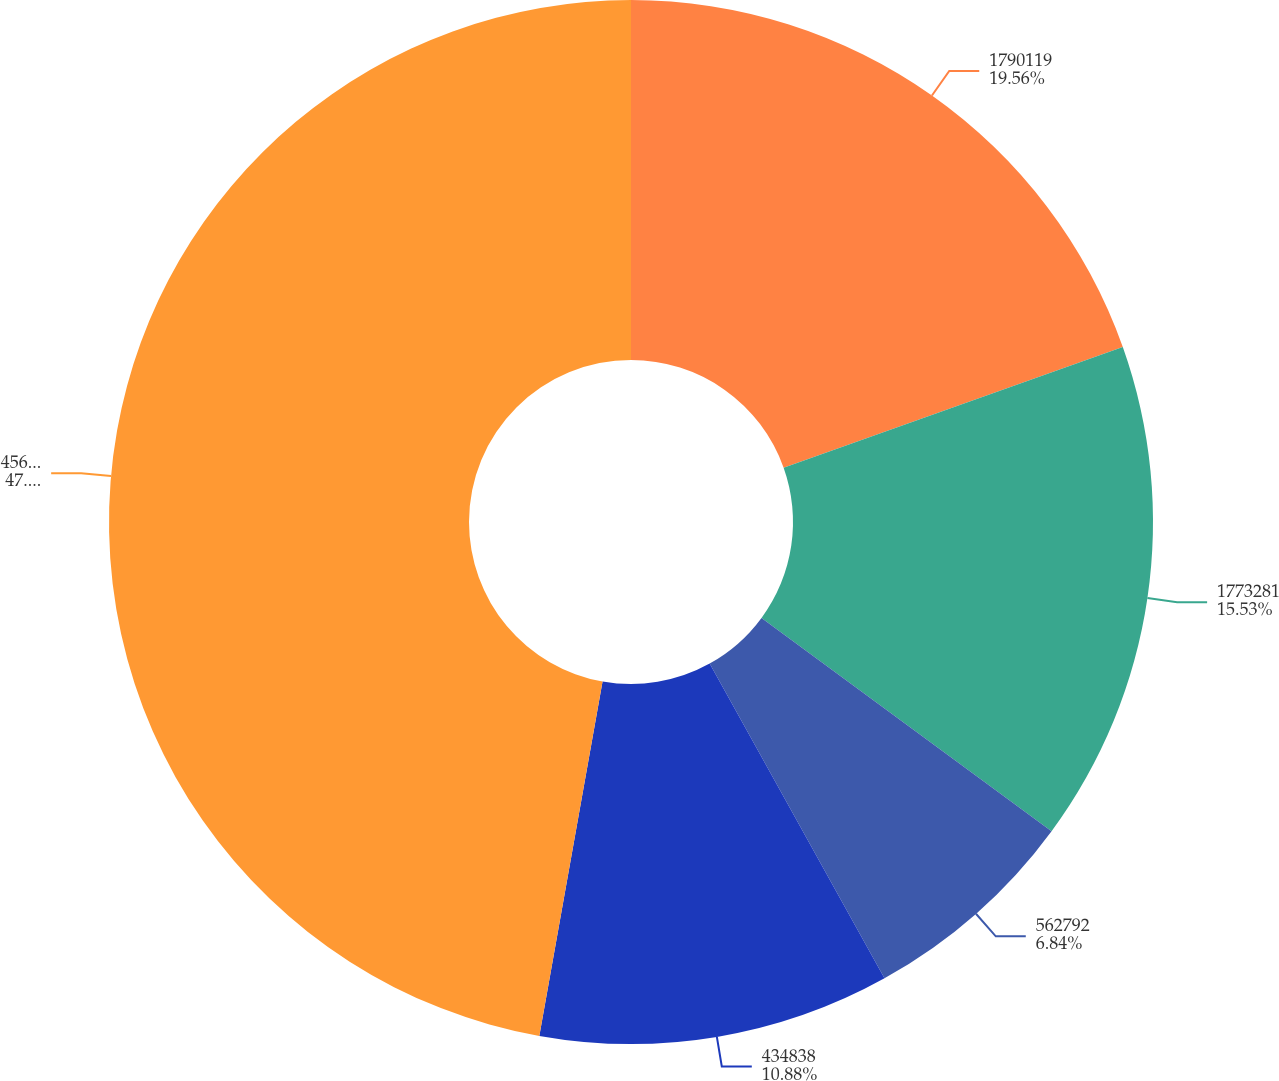Convert chart to OTSL. <chart><loc_0><loc_0><loc_500><loc_500><pie_chart><fcel>1790119<fcel>1773281<fcel>562792<fcel>434838<fcel>4561030<nl><fcel>19.56%<fcel>15.53%<fcel>6.84%<fcel>10.88%<fcel>47.19%<nl></chart> 